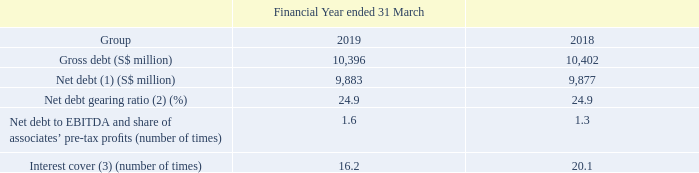Management Discussion and Analysis
Capital Management and Dividend Policy
Notes: (1) Net debt is defined as gross debt less cash and bank balances adjusted for related hedging balances.
(2) Net debt gearing ratio is defined as the ratio of net debt to net capitalisation. Net capitalisation is the aggregate of net debt, shareholders’ funds and non-controlling interests.
(3) Interest cover refers to the ratio of EBITDA and share of associates’ pre-tax profits to net interest expense.
As at 31 March 2019, the Group’s net debt was S$9.9 billion, stable from a year ago. 

As at 31 March 2019, the Group’s net debt was S$9.9 billion, stable from a year ago.
The Group has one of the strongest credit ratings among telecommunication companies in the Asia Pacific region. Singtel is currently rated A1 by Moody’s and A+ by S&P Global Ratings. The Group continues to maintain a healthy capital structure. 

The Group has one of the strongest credit ratings among telecommunication companies in the Asia Pacific region. Singtel is currently rated A1 by Moody’s and A+ by S&P Global Ratings. The Group continues to maintain a healthy capital structure.
For the financial year ended 31 March 2019, the total ordinary dividend payout, including the proposed final dividend, was 17.5 cents per share or 101% of the Group’s underlying net profit and 88% of the Group’s free cash flow (after interest and tax payments). 

For the financial year ended 31 March 2019, the total ordinary dividend payout, including the proposed final dividend, was 17.5 cents per share or 101% of the Group’s underlying net profit and 88% of the Group’s free cash flow (after interest and tax payments).
Singtel is committed to delivering dividends that increase over time with growth in underlying earnings, while maintaining an optimal capital structure and investment grade credit ratings. Barring unforeseen circumstances, it expects to maintain its ordinary dividends at 17.5 cents per share for the next financial year ending 31 March 2020.
What was the total ordinary dividend payout per share? 17.5 cents per share. What is Singtel's credit rating given by Moody's? A1. What is Singtel's credit rating given by S&P Global Ratings? A+. Which year did Singtel have a higher interest cover? 20.1 > 16.2
Answer: 2018. What is the average gross debt across the 2 years?
Answer scale should be: million. ( 10,396 + 10,402 ) / 2
Answer: 10399. How many factors need to be considered when calculating net capitalisation? Net debt##shareholders’ funds##non-controlling interests
answer: 3. 